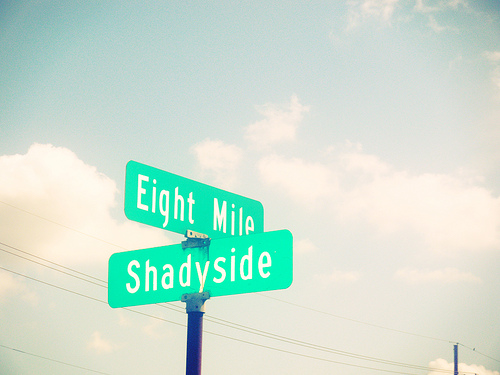What might be the significance of 'Eight Mile' on the top street sign? The term 'Eight Mile' could refer to a specific distance marker, often indicating the eighth mile of a road or highway. Additionally, 'Eight Mile' is famously associated with a road in Detroit, Michigan, and has cultural significance due to its mention in music and film. 